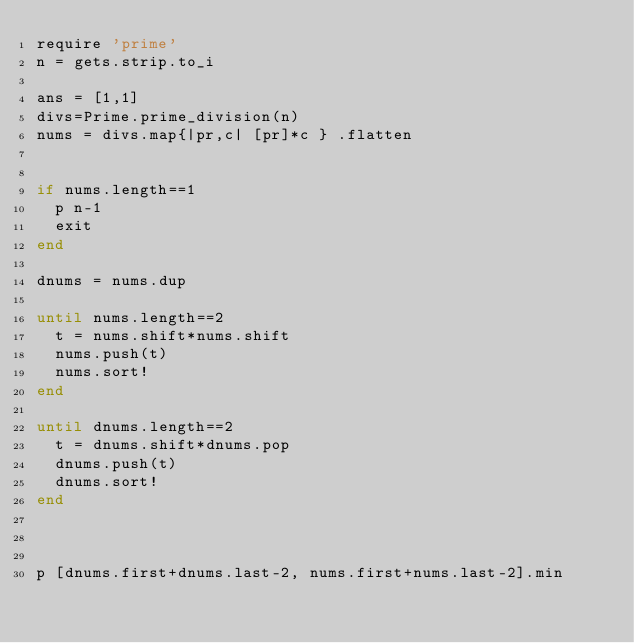<code> <loc_0><loc_0><loc_500><loc_500><_Ruby_>require 'prime'
n = gets.strip.to_i

ans = [1,1]
divs=Prime.prime_division(n)
nums = divs.map{|pr,c| [pr]*c } .flatten


if nums.length==1
  p n-1
  exit
end

dnums = nums.dup

until nums.length==2
  t = nums.shift*nums.shift
  nums.push(t)
  nums.sort!
end

until dnums.length==2
  t = dnums.shift*dnums.pop
  dnums.push(t)
  dnums.sort!
end



p [dnums.first+dnums.last-2, nums.first+nums.last-2].min


</code> 